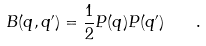<formula> <loc_0><loc_0><loc_500><loc_500>B ( q , q ^ { \prime } ) = \frac { 1 } { 2 } P ( q ) P ( q ^ { \prime } ) \quad .</formula> 